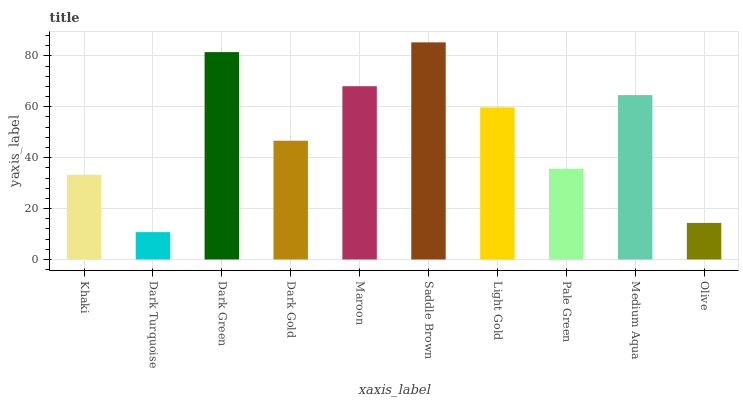Is Dark Green the minimum?
Answer yes or no. No. Is Dark Green the maximum?
Answer yes or no. No. Is Dark Green greater than Dark Turquoise?
Answer yes or no. Yes. Is Dark Turquoise less than Dark Green?
Answer yes or no. Yes. Is Dark Turquoise greater than Dark Green?
Answer yes or no. No. Is Dark Green less than Dark Turquoise?
Answer yes or no. No. Is Light Gold the high median?
Answer yes or no. Yes. Is Dark Gold the low median?
Answer yes or no. Yes. Is Saddle Brown the high median?
Answer yes or no. No. Is Maroon the low median?
Answer yes or no. No. 